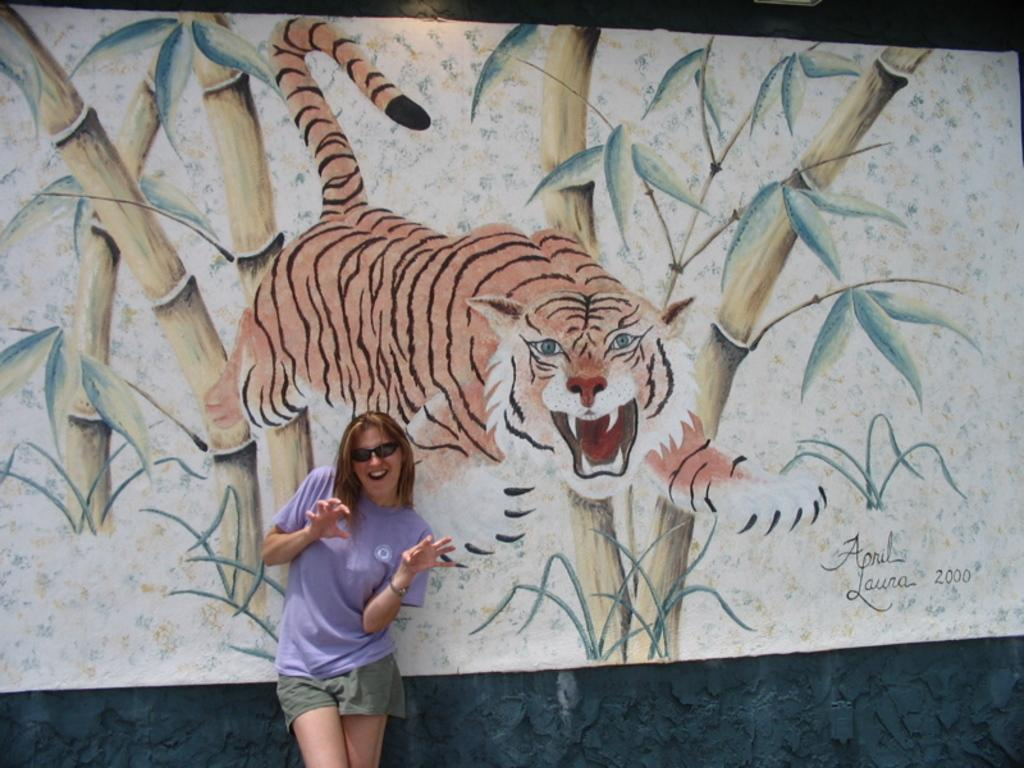Who is present in the image? There is a woman in the image. What is the woman wearing? The woman is wearing glasses. What is the woman's posture in the image? The woman is standing. What can be seen in the background of the image? There is a painting board and a wall in the background of the image. What is written or depicted on the painting board? There is text visible on the painting board. How many spiders are crawling on the woman's glasses in the image? There are no spiders present in the image, so it is not possible to determine how many would be crawling on the woman's glasses. 